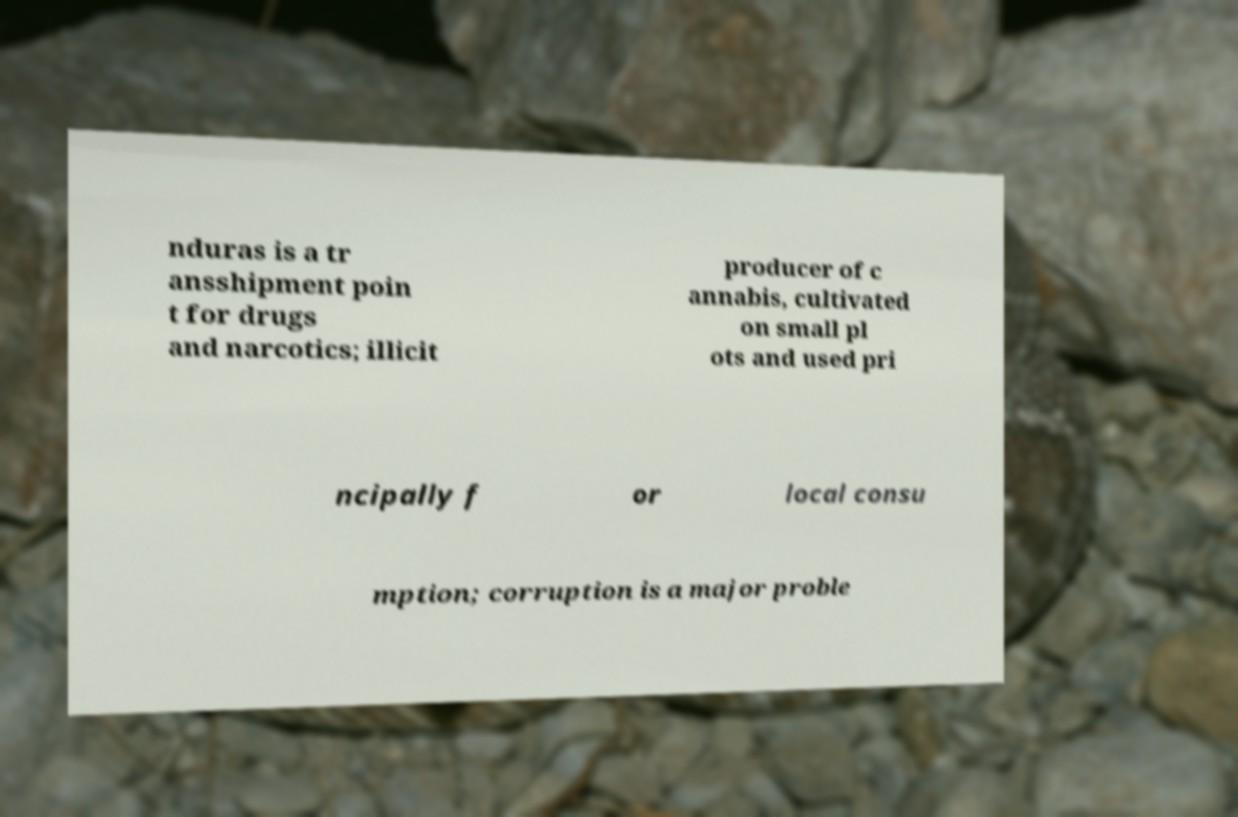There's text embedded in this image that I need extracted. Can you transcribe it verbatim? nduras is a tr ansshipment poin t for drugs and narcotics; illicit producer of c annabis, cultivated on small pl ots and used pri ncipally f or local consu mption; corruption is a major proble 